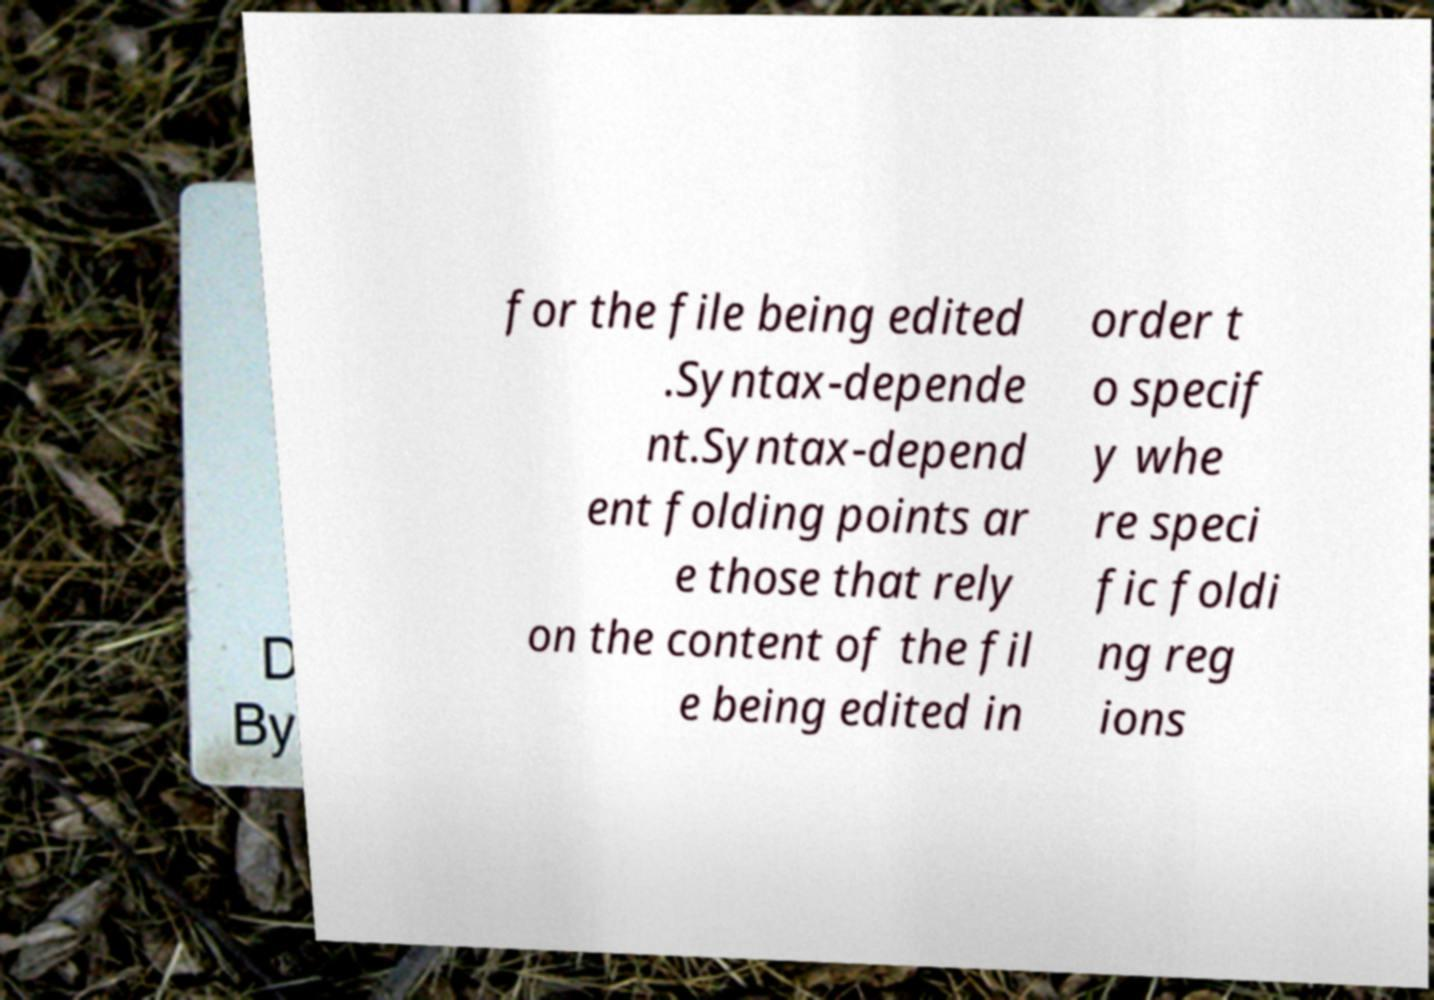I need the written content from this picture converted into text. Can you do that? for the file being edited .Syntax-depende nt.Syntax-depend ent folding points ar e those that rely on the content of the fil e being edited in order t o specif y whe re speci fic foldi ng reg ions 